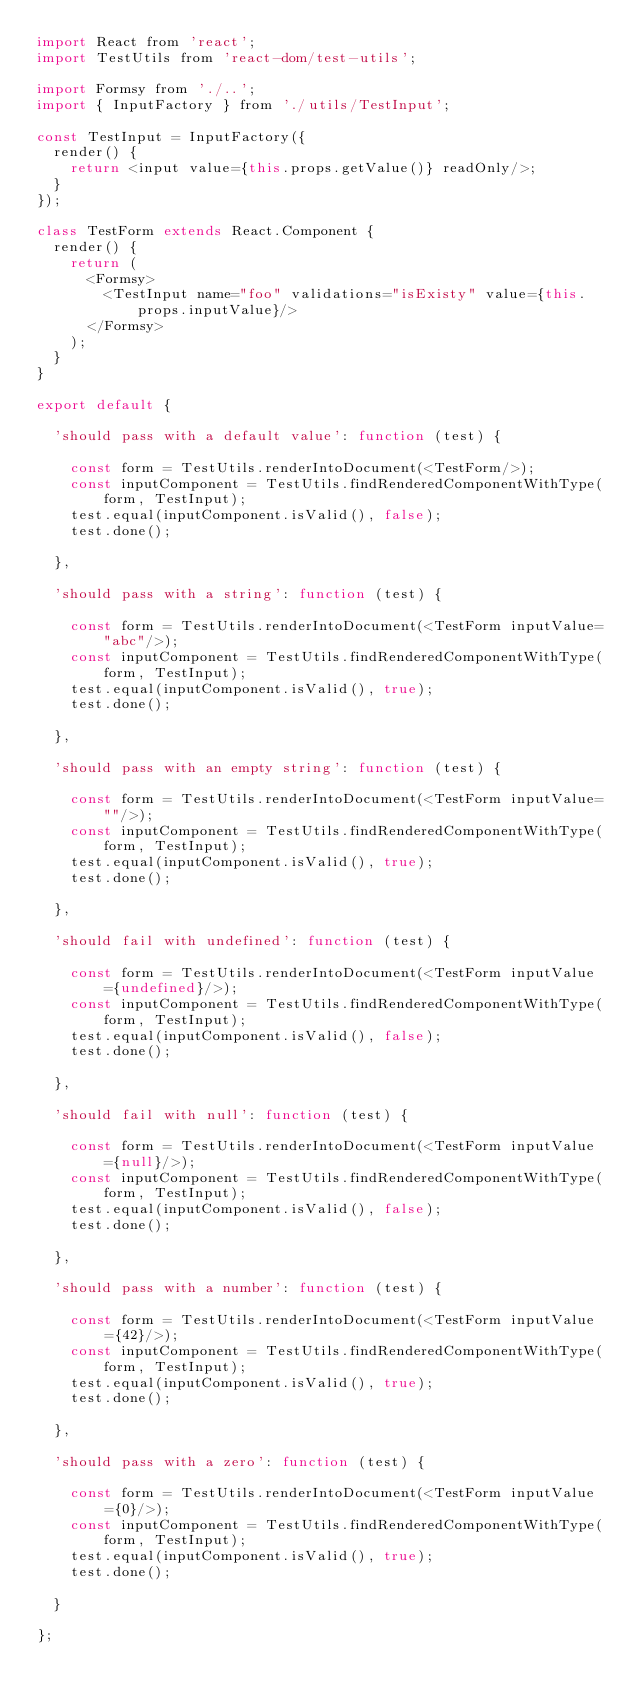<code> <loc_0><loc_0><loc_500><loc_500><_JavaScript_>import React from 'react';
import TestUtils from 'react-dom/test-utils';

import Formsy from './..';
import { InputFactory } from './utils/TestInput';

const TestInput = InputFactory({
  render() {
    return <input value={this.props.getValue()} readOnly/>;
  }
});

class TestForm extends React.Component {
  render() {
    return (
      <Formsy>
        <TestInput name="foo" validations="isExisty" value={this.props.inputValue}/>
      </Formsy>
    );
  }
}

export default {

  'should pass with a default value': function (test) {

    const form = TestUtils.renderIntoDocument(<TestForm/>);
    const inputComponent = TestUtils.findRenderedComponentWithType(form, TestInput);
    test.equal(inputComponent.isValid(), false);
    test.done();

  },

  'should pass with a string': function (test) {

    const form = TestUtils.renderIntoDocument(<TestForm inputValue="abc"/>);
    const inputComponent = TestUtils.findRenderedComponentWithType(form, TestInput);
    test.equal(inputComponent.isValid(), true);
    test.done();

  },

  'should pass with an empty string': function (test) {

    const form = TestUtils.renderIntoDocument(<TestForm inputValue=""/>);
    const inputComponent = TestUtils.findRenderedComponentWithType(form, TestInput);
    test.equal(inputComponent.isValid(), true);
    test.done();

  },

  'should fail with undefined': function (test) {

    const form = TestUtils.renderIntoDocument(<TestForm inputValue={undefined}/>);
    const inputComponent = TestUtils.findRenderedComponentWithType(form, TestInput);
    test.equal(inputComponent.isValid(), false);
    test.done();

  },

  'should fail with null': function (test) {

    const form = TestUtils.renderIntoDocument(<TestForm inputValue={null}/>);
    const inputComponent = TestUtils.findRenderedComponentWithType(form, TestInput);
    test.equal(inputComponent.isValid(), false);
    test.done();

  },

  'should pass with a number': function (test) {

    const form = TestUtils.renderIntoDocument(<TestForm inputValue={42}/>);
    const inputComponent = TestUtils.findRenderedComponentWithType(form, TestInput);
    test.equal(inputComponent.isValid(), true);
    test.done();

  },

  'should pass with a zero': function (test) {

    const form = TestUtils.renderIntoDocument(<TestForm inputValue={0}/>);
    const inputComponent = TestUtils.findRenderedComponentWithType(form, TestInput);
    test.equal(inputComponent.isValid(), true);
    test.done();

  }

};
</code> 